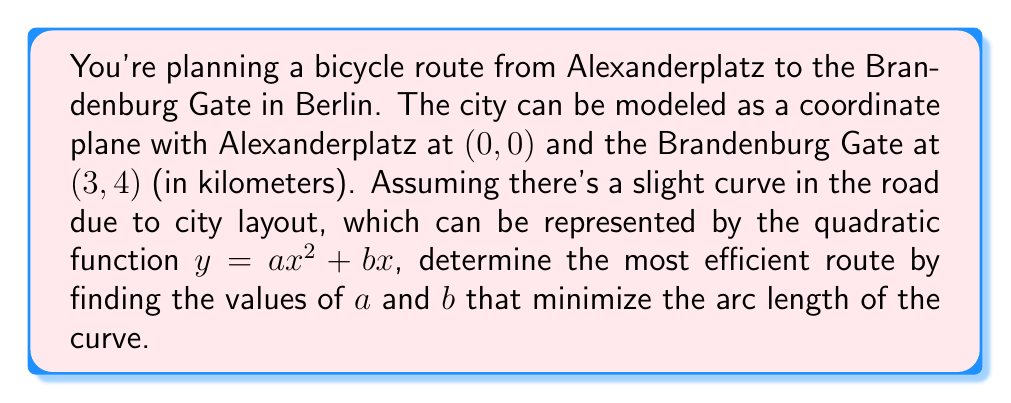Can you answer this question? To solve this problem, we'll follow these steps:

1) The curve must pass through both points: (0, 0) and (3, 4).

2) For (0, 0): $0 = a(0)^2 + b(0)$, which is always true.

3) For (3, 4): $4 = a(3)^2 + b(3)$
   $4 = 9a + 3b$ ... (Equation 1)

4) The arc length of a curve $y = f(x)$ from $x = 0$ to $x = 3$ is given by:

   $$L = \int_0^3 \sqrt{1 + [f'(x)]^2} dx$$

5) In our case, $f'(x) = 2ax + b$, so:

   $$L = \int_0^3 \sqrt{1 + (2ax + b)^2} dx$$

6) To minimize L, we need to minimize the integral. This occurs when the integrand is as close to 1 as possible, which happens when $(2ax + b)^2$ is as close to 0 as possible.

7) The average value of $(2ax + b)^2$ over [0, 3] should be minimized:

   $$\frac{1}{3}\int_0^3 (2ax + b)^2 dx = \frac{1}{3}[4a^2x^3/3 + 2abx^2 + b^2x]_0^3$$
   $$= 4a^2 + 3ab + b^2$$

8) Minimize this subject to the constraint from Equation 1:
   $4 = 9a + 3b$, or $b = \frac{4}{3} - 3a$

9) Substituting this into the expression to minimize:

   $$4a^2 + 3a(\frac{4}{3} - 3a) + (\frac{4}{3} - 3a)^2$$
   $$= 4a^2 + 4 - 9a^2 + \frac{16}{9} - 8a + 9a^2$$
   $$= 4a^2 - 8a + \frac{52}{9}$$

10) To minimize, differentiate and set to zero:

    $$8a - 8 = 0$$
    $$a = 1$$

11) Substituting back:

    $$b = \frac{4}{3} - 3(1) = -\frac{5}{3}$$

Therefore, the most efficient route is described by the curve:

$$y = x^2 - \frac{5}{3}x$$
Answer: $y = x^2 - \frac{5}{3}x$ 